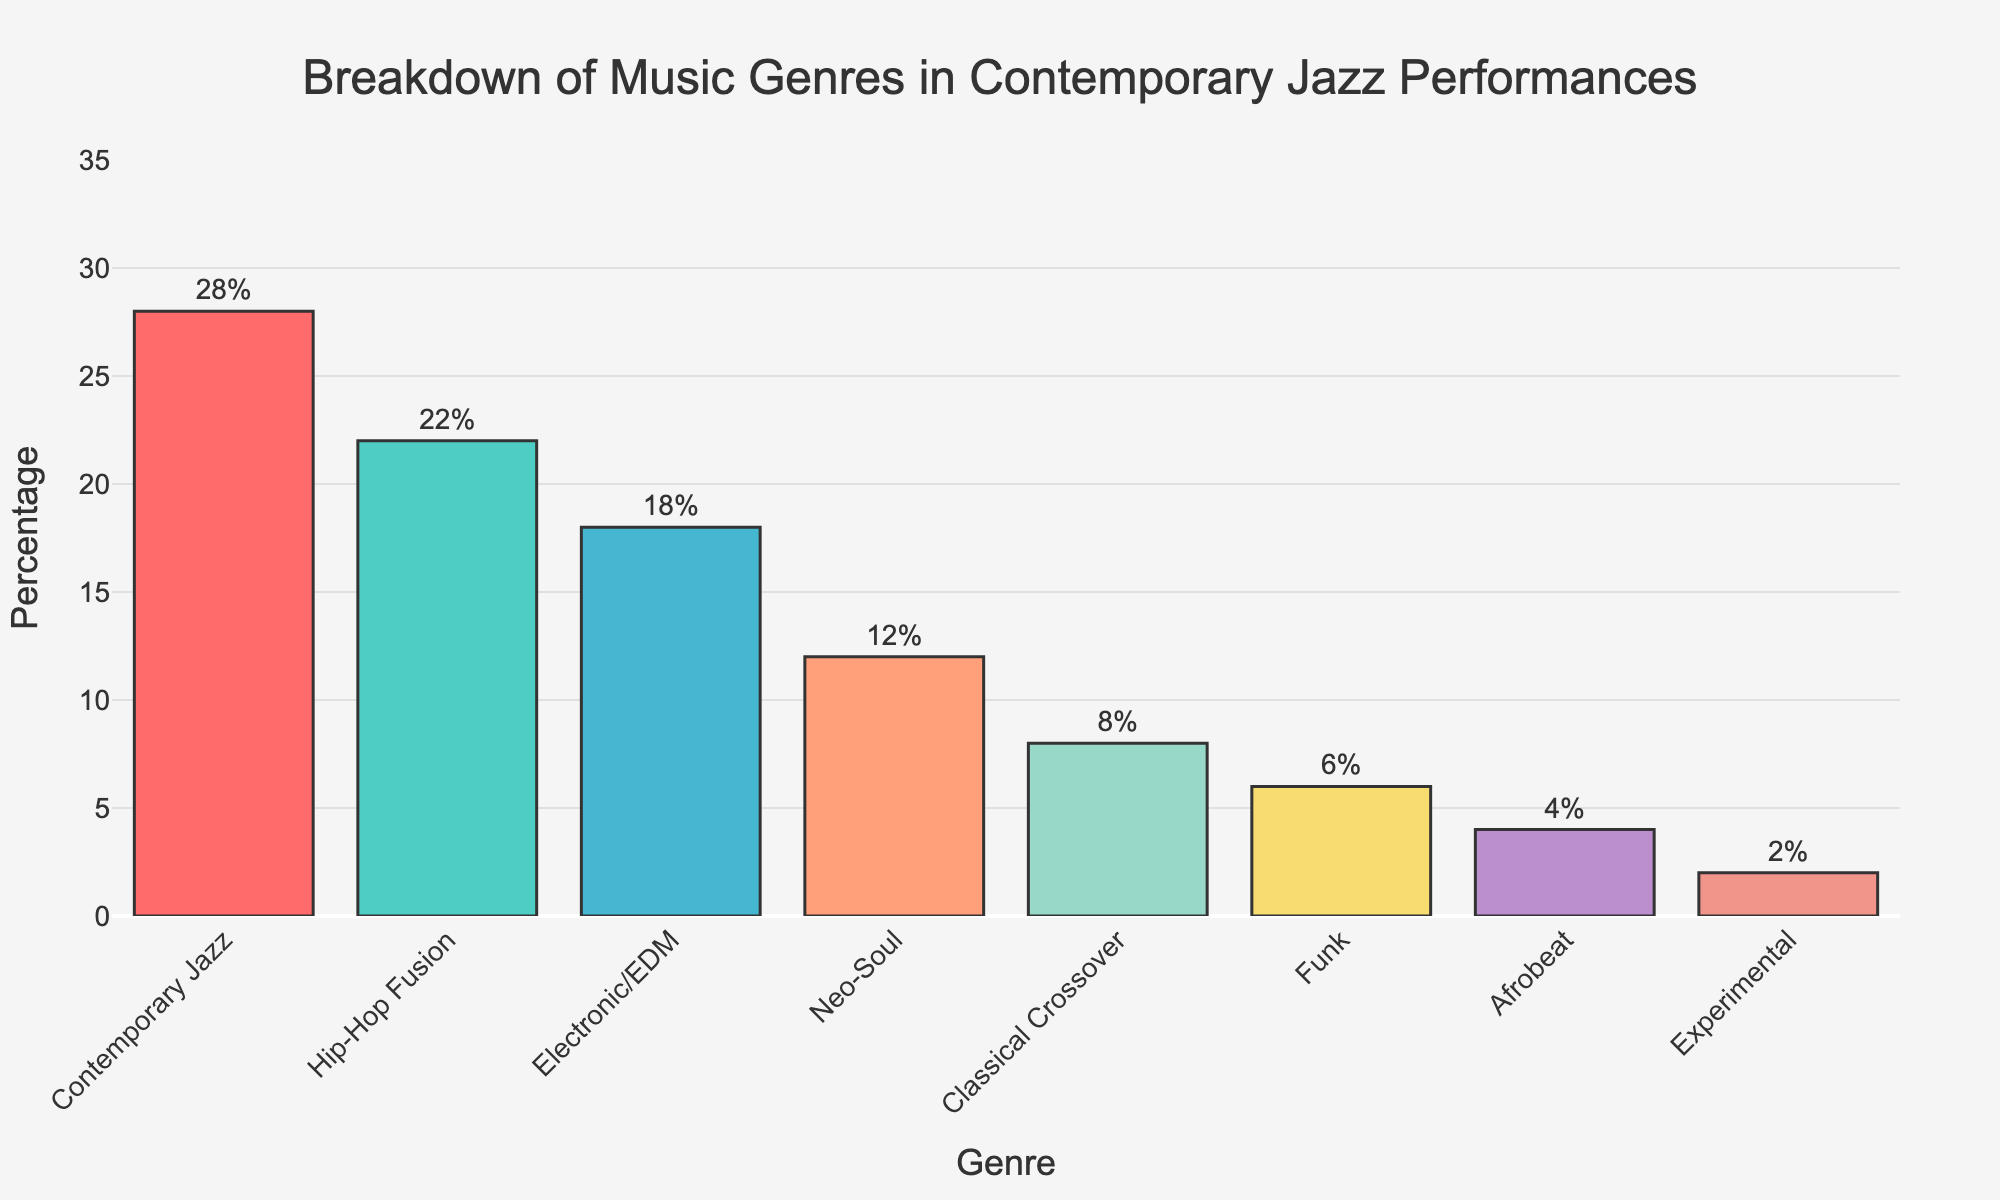What genre has the highest percentage in contemporary jazz performances? Look at the bar chart and identify the tallest bar. The tallest bar represents "Contemporary Jazz" with a percentage of 28%.
Answer: Contemporary Jazz Which two genres have a combined percentage of 26%? Add up the percentages of genres to find the combination that equals 26%. Hip-Hop Fusion (22%) and Experimental (4%) together make 26%.
Answer: Hip-Hop Fusion and Experimental Is Hip-Hop Fusion more popular than Electronic/EDM in contemporary jazz performances? Compare the heights of the bars for Hip-Hop Fusion and Electronic/EDM. Hip-Hop Fusion has 22%, and Electronic/EDM has 18%.
Answer: Yes By how many percentage points does Contemporary Jazz exceed Funk? Subtract the percentage of Funk from that of Contemporary Jazz (28% - 6% = 22%).
Answer: 22 percentage points Which genre has the smallest representation in contemporary jazz performances? Identify the shortest bar on the chart, which represents Experimental with 2%.
Answer: Experimental How much more popular is Neo-Soul compared to Afrobeat? Subtract the percentage of Afrobeat from Neo-Soul (12% - 4% = 8%).
Answer: 8 percentage points What is the difference in percentage between the second and third most popular genres? Identify the second and third highest percentages (Hip-Hop Fusion at 22% and Electronic/EDM at 18%) and subtract them (22% - 18% = 4%).
Answer: 4 percentage points What is the median percentage value of all genres listed? To find the median, first list the percentages in ascending order: 2%, 4%, 6%, 8%, 12%, 18%, 22%, 28%. The median is the average of the middle values: (12% + 18%) / 2 = 15%.
Answer: 15% Which genre's bar is colored in blue-green? By examining the bar colors, the blue-green one represents Hip-Hop Fusion.
Answer: Hip-Hop Fusion 